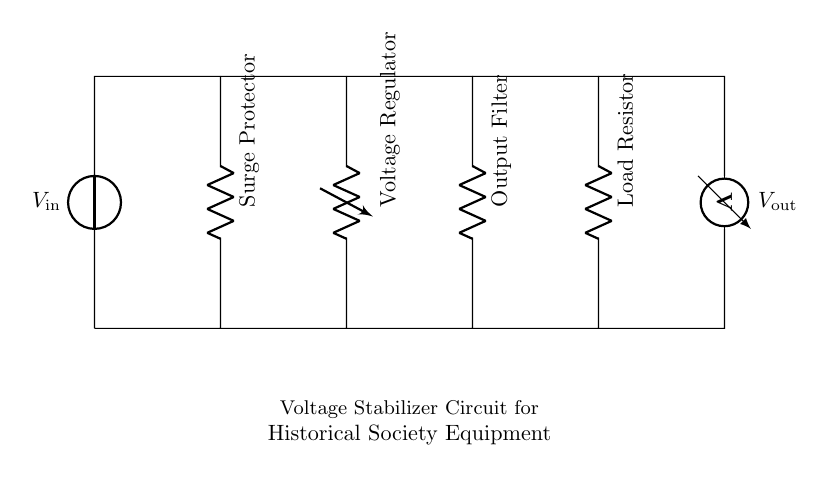What component is used for surging protection? The component labeled as "Surge Protector" is responsible for protecting the circuit from voltage spikes or surges. It is placed at the beginning of the circuit, receiving the input voltage.
Answer: Surge Protector What is the role of the voltage regulator in this circuit? The voltage regulator maintains a steady output voltage despite fluctuations in the input voltage or varying load conditions. It ensures that sensitive archival equipment receives the correct voltage level.
Answer: Steady output voltage How many resistors are present in the circuit? There are three resistors in the circuit: the Output Filter, Load Resistor, and Surge Protector (assuming it may provide some resistive protection). Counting them provides a total of three.
Answer: Three What is the function of the output filter? The output filter smooths out any fluctuations in voltage that may affect the performance of sensitive equipment. It reduces ripple in the output voltage, ensuring a cleaner signal.
Answer: Smooths out fluctuations What voltage is measured at the output? The output voltage is indicated by the component labeled as "V_out," which shows the voltage level being delivered to the load (sensitive equipment).
Answer: V_out Why is it important to use a voltage stabilizer for archival equipment? A voltage stabilizer protects sensitive archival equipment from voltage fluctuations that could cause damage or loss of data. Stabilized voltage contributes to the longevity and reliability of such equipment.
Answer: Protects from fluctuations 